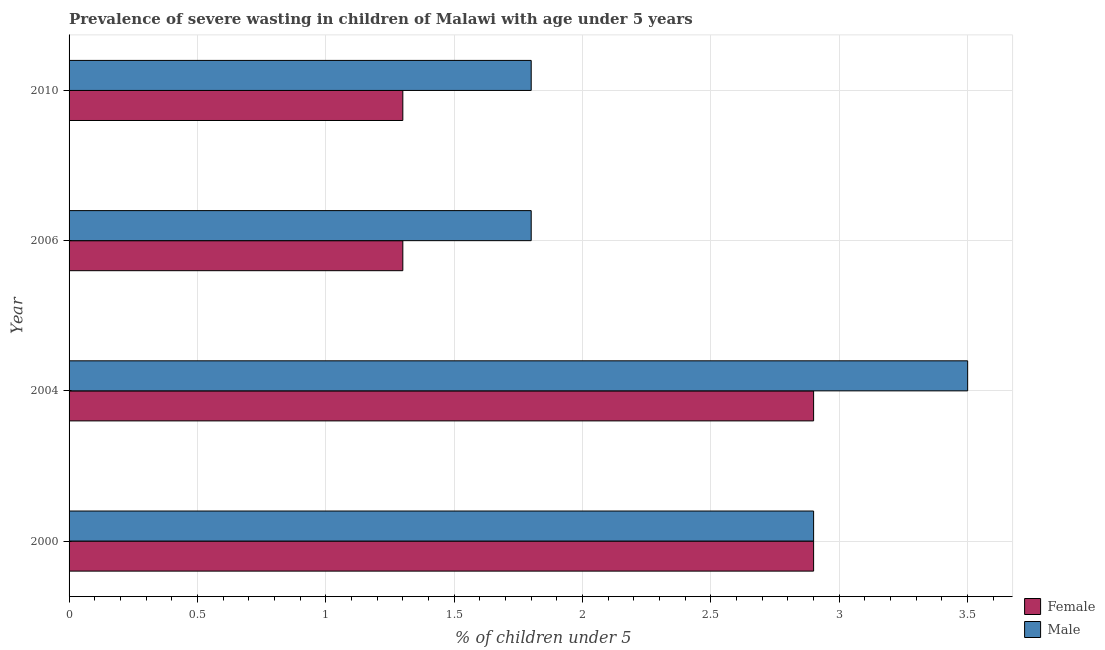How many groups of bars are there?
Provide a succinct answer. 4. What is the label of the 4th group of bars from the top?
Offer a very short reply. 2000. What is the percentage of undernourished male children in 2004?
Your answer should be compact. 3.5. Across all years, what is the maximum percentage of undernourished male children?
Offer a terse response. 3.5. Across all years, what is the minimum percentage of undernourished female children?
Offer a very short reply. 1.3. What is the total percentage of undernourished female children in the graph?
Make the answer very short. 8.4. What is the difference between the percentage of undernourished male children in 2000 and the percentage of undernourished female children in 2006?
Your answer should be very brief. 1.6. What is the average percentage of undernourished female children per year?
Your answer should be compact. 2.1. In the year 2004, what is the difference between the percentage of undernourished male children and percentage of undernourished female children?
Ensure brevity in your answer.  0.6. What is the ratio of the percentage of undernourished male children in 2000 to that in 2004?
Provide a short and direct response. 0.83. Is the difference between the percentage of undernourished male children in 2004 and 2006 greater than the difference between the percentage of undernourished female children in 2004 and 2006?
Keep it short and to the point. Yes. In how many years, is the percentage of undernourished female children greater than the average percentage of undernourished female children taken over all years?
Your answer should be very brief. 2. What does the 2nd bar from the top in 2006 represents?
Your response must be concise. Female. What does the 1st bar from the bottom in 2006 represents?
Offer a terse response. Female. Are all the bars in the graph horizontal?
Give a very brief answer. Yes. How many years are there in the graph?
Give a very brief answer. 4. Are the values on the major ticks of X-axis written in scientific E-notation?
Your answer should be compact. No. Does the graph contain grids?
Ensure brevity in your answer.  Yes. How many legend labels are there?
Give a very brief answer. 2. How are the legend labels stacked?
Give a very brief answer. Vertical. What is the title of the graph?
Make the answer very short. Prevalence of severe wasting in children of Malawi with age under 5 years. What is the label or title of the X-axis?
Offer a terse response.  % of children under 5. What is the label or title of the Y-axis?
Offer a terse response. Year. What is the  % of children under 5 in Female in 2000?
Keep it short and to the point. 2.9. What is the  % of children under 5 in Male in 2000?
Provide a succinct answer. 2.9. What is the  % of children under 5 of Female in 2004?
Provide a short and direct response. 2.9. What is the  % of children under 5 of Male in 2004?
Make the answer very short. 3.5. What is the  % of children under 5 in Female in 2006?
Your answer should be compact. 1.3. What is the  % of children under 5 in Male in 2006?
Your answer should be very brief. 1.8. What is the  % of children under 5 of Female in 2010?
Your answer should be compact. 1.3. What is the  % of children under 5 in Male in 2010?
Ensure brevity in your answer.  1.8. Across all years, what is the maximum  % of children under 5 in Female?
Provide a succinct answer. 2.9. Across all years, what is the minimum  % of children under 5 of Female?
Offer a terse response. 1.3. Across all years, what is the minimum  % of children under 5 of Male?
Provide a succinct answer. 1.8. What is the total  % of children under 5 in Female in the graph?
Your answer should be very brief. 8.4. What is the total  % of children under 5 of Male in the graph?
Your answer should be very brief. 10. What is the difference between the  % of children under 5 of Female in 2000 and that in 2006?
Provide a succinct answer. 1.6. What is the difference between the  % of children under 5 of Female in 2004 and that in 2010?
Provide a short and direct response. 1.6. What is the difference between the  % of children under 5 of Female in 2006 and that in 2010?
Offer a terse response. 0. What is the difference between the  % of children under 5 of Male in 2006 and that in 2010?
Make the answer very short. 0. What is the difference between the  % of children under 5 of Female in 2000 and the  % of children under 5 of Male in 2004?
Your answer should be compact. -0.6. What is the difference between the  % of children under 5 of Female in 2006 and the  % of children under 5 of Male in 2010?
Provide a succinct answer. -0.5. What is the average  % of children under 5 in Male per year?
Give a very brief answer. 2.5. In the year 2000, what is the difference between the  % of children under 5 in Female and  % of children under 5 in Male?
Provide a succinct answer. 0. In the year 2004, what is the difference between the  % of children under 5 of Female and  % of children under 5 of Male?
Offer a very short reply. -0.6. What is the ratio of the  % of children under 5 in Male in 2000 to that in 2004?
Ensure brevity in your answer.  0.83. What is the ratio of the  % of children under 5 in Female in 2000 to that in 2006?
Provide a succinct answer. 2.23. What is the ratio of the  % of children under 5 in Male in 2000 to that in 2006?
Your response must be concise. 1.61. What is the ratio of the  % of children under 5 of Female in 2000 to that in 2010?
Ensure brevity in your answer.  2.23. What is the ratio of the  % of children under 5 in Male in 2000 to that in 2010?
Keep it short and to the point. 1.61. What is the ratio of the  % of children under 5 of Female in 2004 to that in 2006?
Your answer should be very brief. 2.23. What is the ratio of the  % of children under 5 in Male in 2004 to that in 2006?
Ensure brevity in your answer.  1.94. What is the ratio of the  % of children under 5 in Female in 2004 to that in 2010?
Your answer should be compact. 2.23. What is the ratio of the  % of children under 5 in Male in 2004 to that in 2010?
Your answer should be compact. 1.94. What is the ratio of the  % of children under 5 in Female in 2006 to that in 2010?
Keep it short and to the point. 1. What is the difference between the highest and the second highest  % of children under 5 of Male?
Your response must be concise. 0.6. What is the difference between the highest and the lowest  % of children under 5 of Female?
Offer a terse response. 1.6. 